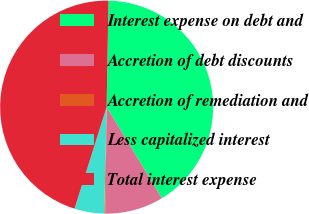Convert chart. <chart><loc_0><loc_0><loc_500><loc_500><pie_chart><fcel>Interest expense on debt and<fcel>Accretion of debt discounts<fcel>Accretion of remediation and<fcel>Less capitalized interest<fcel>Total interest expense<nl><fcel>41.05%<fcel>8.87%<fcel>0.17%<fcel>4.52%<fcel>45.4%<nl></chart> 